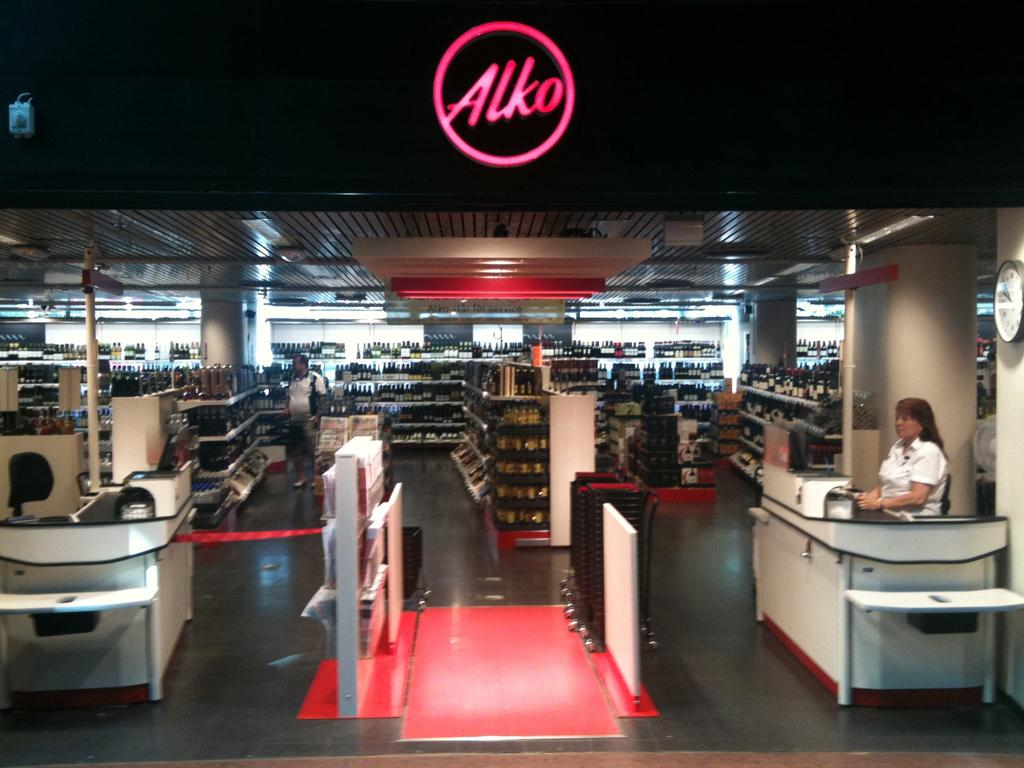<image>
Summarize the visual content of the image. the interior of Alko with a woman sitting in the front register 